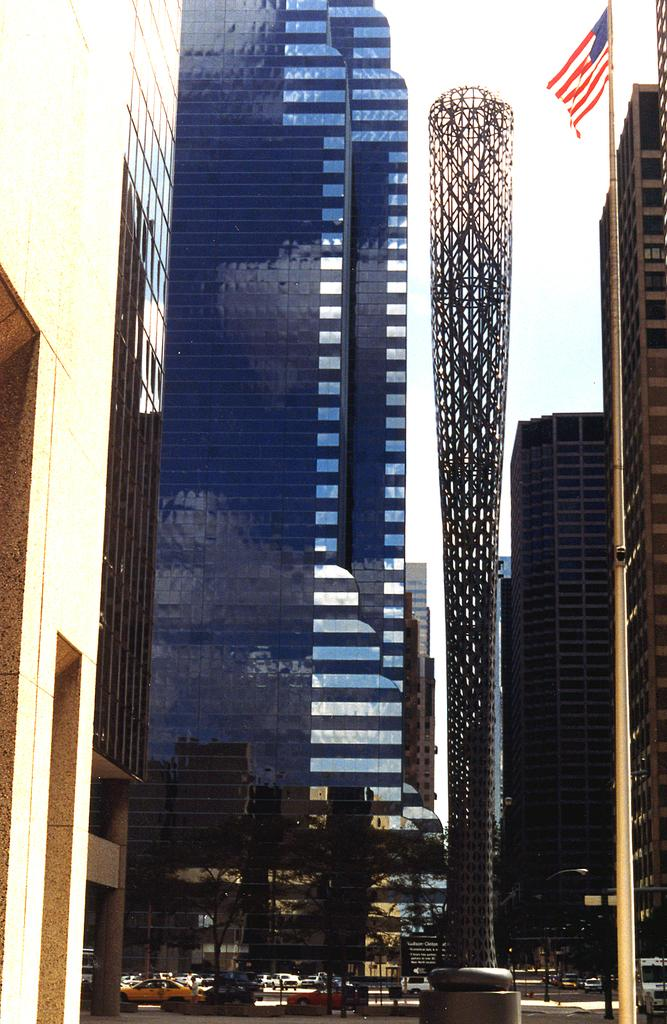What type of structures can be seen in the image? There are buildings in the image. What else can be seen in the image besides buildings? There are trees, vehicles, and a flag on a pole in the image. What is visible in the background of the image? The sky is visible in the background of the image. What type of wool is being used to make the basket in the image? There is no basket or wool present in the image. What is the condition of the flag in the image? The flag is not mentioned to be in any specific condition in the image. 